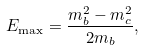Convert formula to latex. <formula><loc_0><loc_0><loc_500><loc_500>E _ { \max } = \frac { m _ { b } ^ { 2 } - m _ { c } ^ { 2 } } { 2 m _ { b } } ,</formula> 